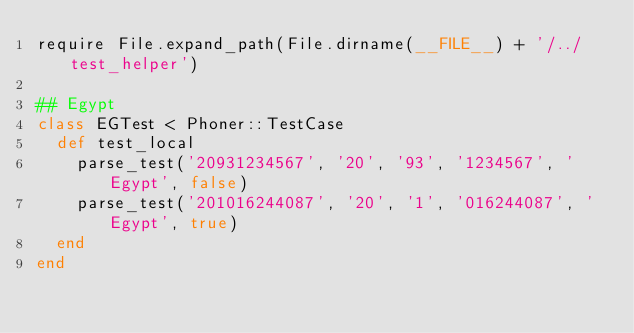Convert code to text. <code><loc_0><loc_0><loc_500><loc_500><_Ruby_>require File.expand_path(File.dirname(__FILE__) + '/../test_helper')

## Egypt
class EGTest < Phoner::TestCase
  def test_local
    parse_test('20931234567', '20', '93', '1234567', 'Egypt', false)
    parse_test('201016244087', '20', '1', '016244087', 'Egypt', true)
  end
end
</code> 